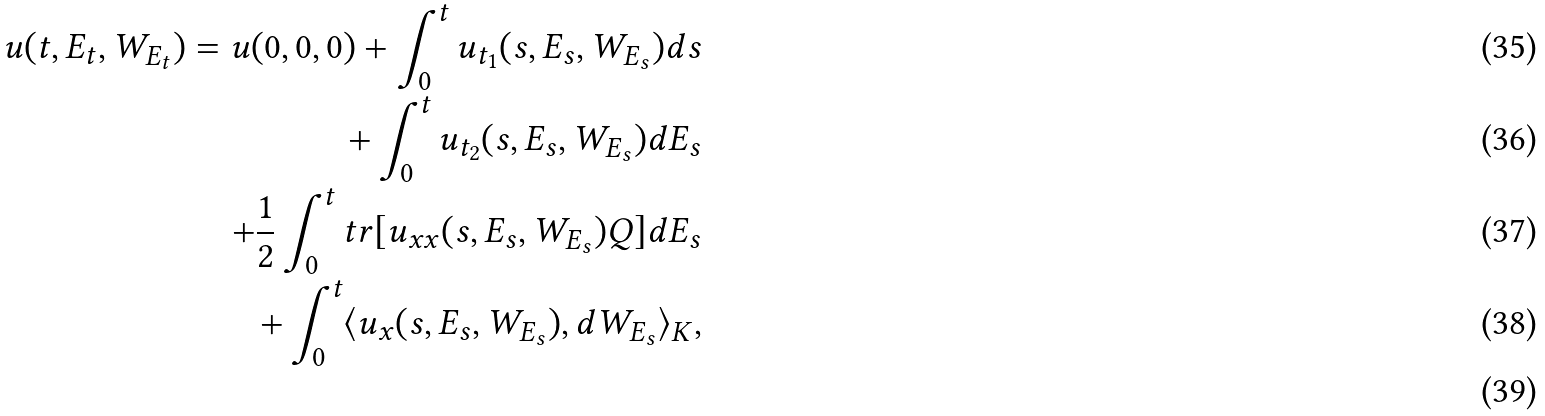Convert formula to latex. <formula><loc_0><loc_0><loc_500><loc_500>u ( t , E _ { t } , W _ { E _ { t } } ) = u ( 0 , 0 , 0 ) + \int _ { 0 } ^ { t } u _ { t _ { 1 } } ( s , E _ { s } , W _ { E _ { s } } ) d s \\ + \int _ { 0 } ^ { t } u _ { t _ { 2 } } ( s , E _ { s } , W _ { E _ { s } } ) d E _ { s } \\ + \frac { 1 } { 2 } \int _ { 0 } ^ { t } t r [ u _ { x x } ( s , E _ { s } , W _ { E _ { s } } ) Q ] d E _ { s } \\ + \int _ { 0 } ^ { t } \langle u _ { x } ( s , E _ { s } , W _ { E _ { s } } ) , d W _ { E _ { s } } \rangle _ { K } , \\</formula> 